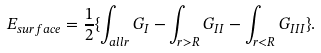<formula> <loc_0><loc_0><loc_500><loc_500>E _ { s u r f a c e } = \frac { 1 } { 2 } \{ \int _ { a l l r } G _ { I } - \int _ { r > R } G _ { I I } - \int _ { r < R } G _ { I I I } \} .</formula> 